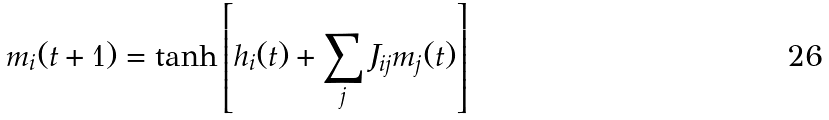<formula> <loc_0><loc_0><loc_500><loc_500>m _ { i } ( t + 1 ) = \tanh \left [ h _ { i } ( t ) + \sum _ { j } J _ { i j } m _ { j } ( t ) \right ]</formula> 